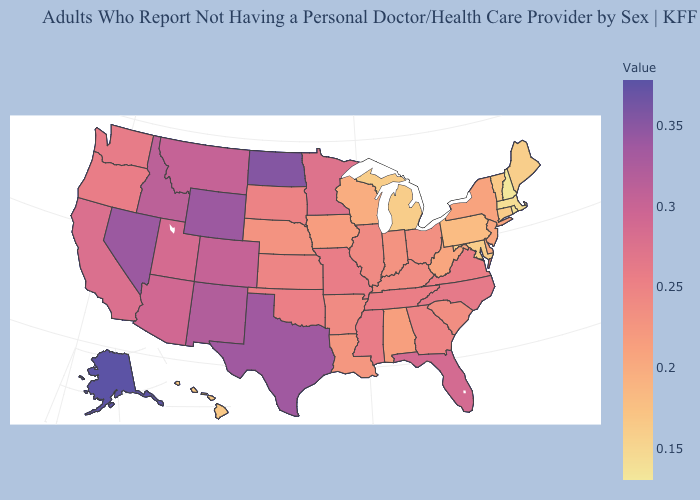Does Alaska have the highest value in the West?
Write a very short answer. Yes. Which states have the lowest value in the USA?
Give a very brief answer. New Hampshire. Does Kansas have the highest value in the MidWest?
Answer briefly. No. Does Florida have a higher value than West Virginia?
Quick response, please. Yes. Among the states that border North Carolina , which have the lowest value?
Concise answer only. South Carolina. Is the legend a continuous bar?
Give a very brief answer. Yes. 